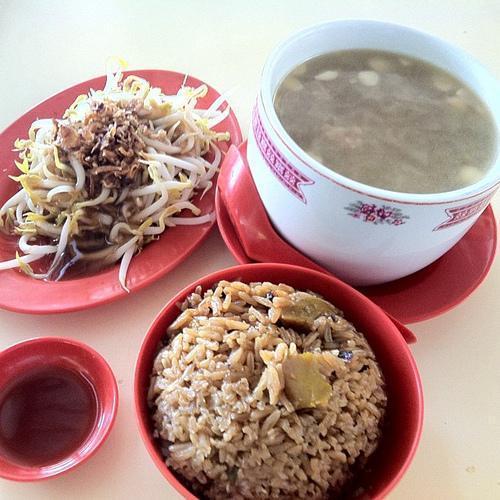How many dishes are there?
Give a very brief answer. 4. How many food items are pictured?
Give a very brief answer. 4. How many condiments are visible?
Give a very brief answer. 1. How many grain dishes are visible?
Give a very brief answer. 1. How many people will the food feed?
Give a very brief answer. 1. How many bowls of soup are there?
Give a very brief answer. 1. How many different kinds of food are there?
Give a very brief answer. 3. How many bowls have liquid in them?
Give a very brief answer. 2. 